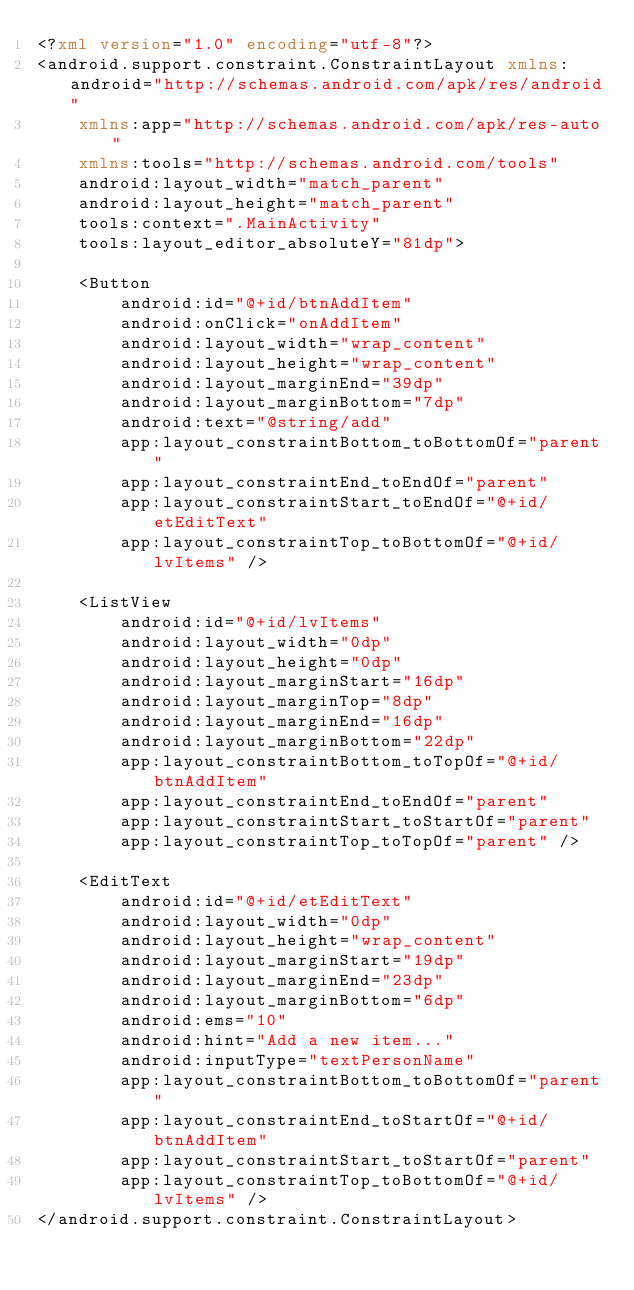<code> <loc_0><loc_0><loc_500><loc_500><_XML_><?xml version="1.0" encoding="utf-8"?>
<android.support.constraint.ConstraintLayout xmlns:android="http://schemas.android.com/apk/res/android"
    xmlns:app="http://schemas.android.com/apk/res-auto"
    xmlns:tools="http://schemas.android.com/tools"
    android:layout_width="match_parent"
    android:layout_height="match_parent"
    tools:context=".MainActivity"
    tools:layout_editor_absoluteY="81dp">

    <Button
        android:id="@+id/btnAddItem"
        android:onClick="onAddItem"
        android:layout_width="wrap_content"
        android:layout_height="wrap_content"
        android:layout_marginEnd="39dp"
        android:layout_marginBottom="7dp"
        android:text="@string/add"
        app:layout_constraintBottom_toBottomOf="parent"
        app:layout_constraintEnd_toEndOf="parent"
        app:layout_constraintStart_toEndOf="@+id/etEditText"
        app:layout_constraintTop_toBottomOf="@+id/lvItems" />

    <ListView
        android:id="@+id/lvItems"
        android:layout_width="0dp"
        android:layout_height="0dp"
        android:layout_marginStart="16dp"
        android:layout_marginTop="8dp"
        android:layout_marginEnd="16dp"
        android:layout_marginBottom="22dp"
        app:layout_constraintBottom_toTopOf="@+id/btnAddItem"
        app:layout_constraintEnd_toEndOf="parent"
        app:layout_constraintStart_toStartOf="parent"
        app:layout_constraintTop_toTopOf="parent" />

    <EditText
        android:id="@+id/etEditText"
        android:layout_width="0dp"
        android:layout_height="wrap_content"
        android:layout_marginStart="19dp"
        android:layout_marginEnd="23dp"
        android:layout_marginBottom="6dp"
        android:ems="10"
        android:hint="Add a new item..."
        android:inputType="textPersonName"
        app:layout_constraintBottom_toBottomOf="parent"
        app:layout_constraintEnd_toStartOf="@+id/btnAddItem"
        app:layout_constraintStart_toStartOf="parent"
        app:layout_constraintTop_toBottomOf="@+id/lvItems" />
</android.support.constraint.ConstraintLayout></code> 